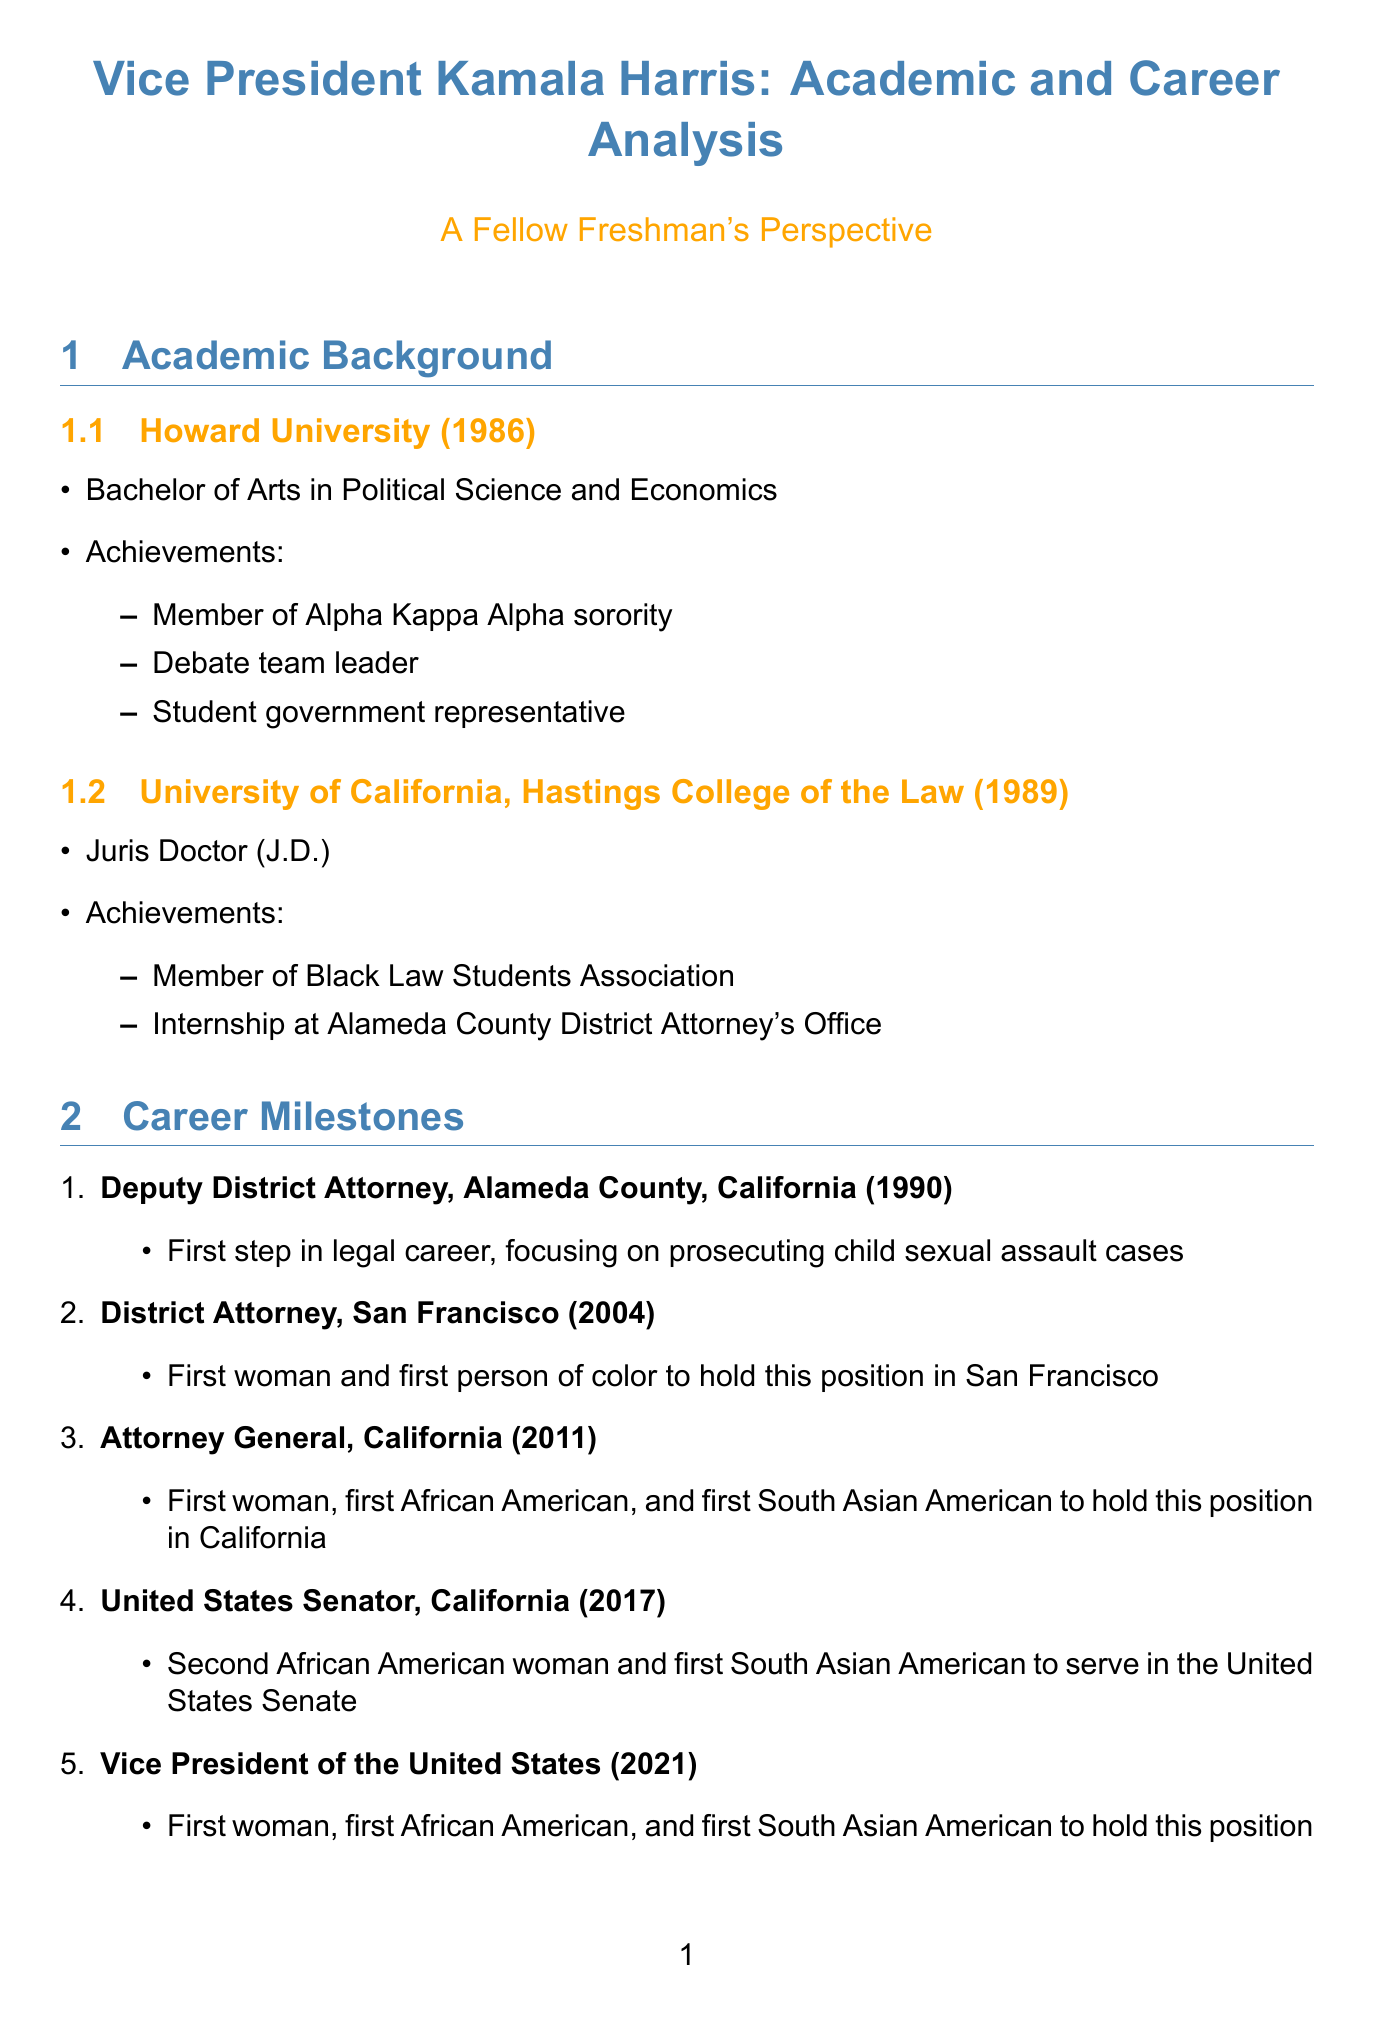What degree did Kamala Harris earn at Howard University? The document states that she earned a Bachelor of Arts in Political Science and Economics at Howard University.
Answer: Bachelor of Arts in Political Science and Economics What was Kamala Harris's position in 2011? According to the document, in 2011, she held the position of Attorney General of California.
Answer: Attorney General Which sorority was Kamala Harris a member of during her time at Howard University? The document mentions that she was a member of Alpha Kappa Alpha sorority.
Answer: Alpha Kappa Alpha How many significant milestones are listed in Kamala Harris's career? The document enumerates five significant milestones in her career.
Answer: Five What strategy does the document suggest for gaining practical experience? It highlights the importance of seeking mentorship and internships for gaining practical experience.
Answer: Seek mentorship and internships Which significant achievement did Kamala Harris accomplish in 2021? The document states that she became the Vice President of the United States in 2021.
Answer: Vice President of the United States What is one of the key lessons for freshmen highlighted in the document? The document emphasizes setting ambitious goals as a key lesson for freshmen.
Answer: Set ambitious goals What type of law degree did Kamala Harris earn? According to the document, she earned a Juris Doctor (J.D.) from UC Hastings.
Answer: Juris Doctor (J.D.) What involvement helped develop Kamala Harris's leadership skills? The document states that her involvement in the debate team helped develop her leadership skills.
Answer: Debate team 